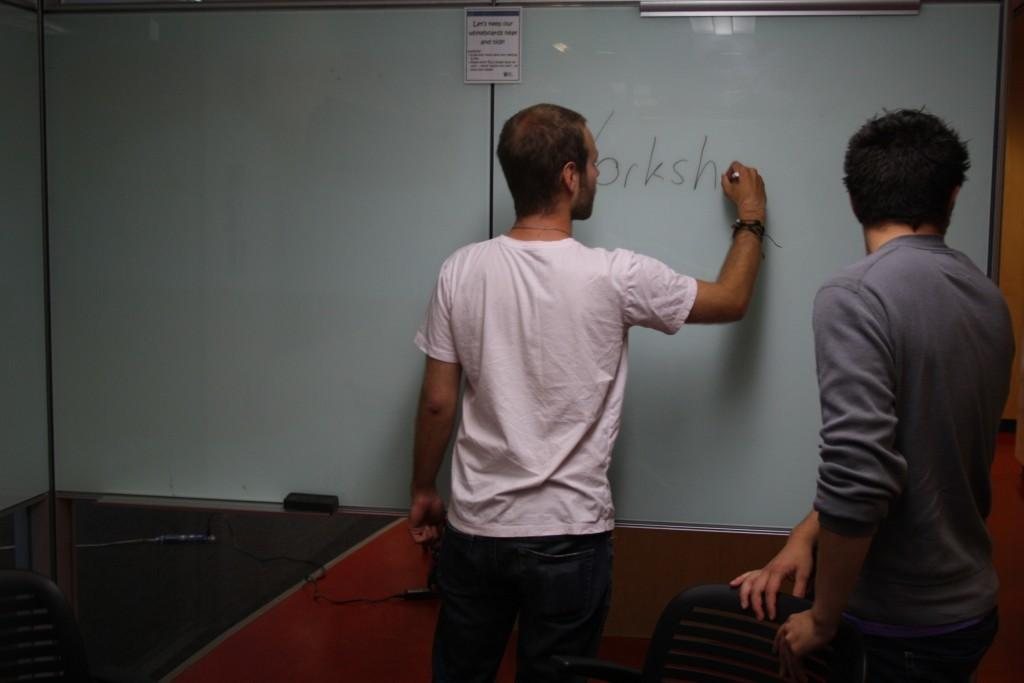<image>
Write a terse but informative summary of the picture. A man writes on the white board behind letter H. 